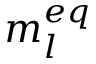<formula> <loc_0><loc_0><loc_500><loc_500>m _ { l } ^ { e q }</formula> 